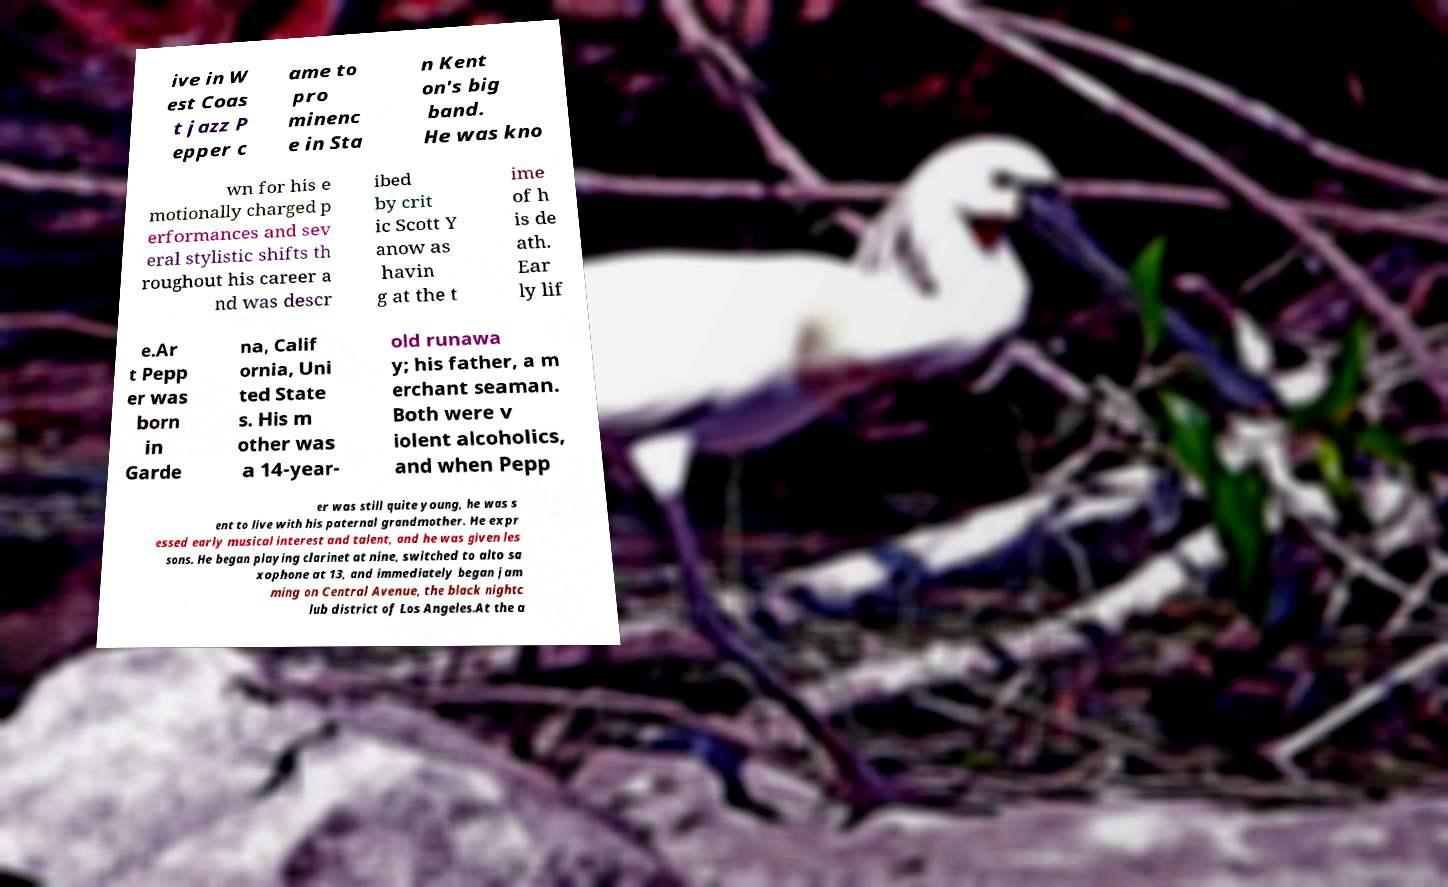For documentation purposes, I need the text within this image transcribed. Could you provide that? ive in W est Coas t jazz P epper c ame to pro minenc e in Sta n Kent on's big band. He was kno wn for his e motionally charged p erformances and sev eral stylistic shifts th roughout his career a nd was descr ibed by crit ic Scott Y anow as havin g at the t ime of h is de ath. Ear ly lif e.Ar t Pepp er was born in Garde na, Calif ornia, Uni ted State s. His m other was a 14-year- old runawa y; his father, a m erchant seaman. Both were v iolent alcoholics, and when Pepp er was still quite young, he was s ent to live with his paternal grandmother. He expr essed early musical interest and talent, and he was given les sons. He began playing clarinet at nine, switched to alto sa xophone at 13, and immediately began jam ming on Central Avenue, the black nightc lub district of Los Angeles.At the a 